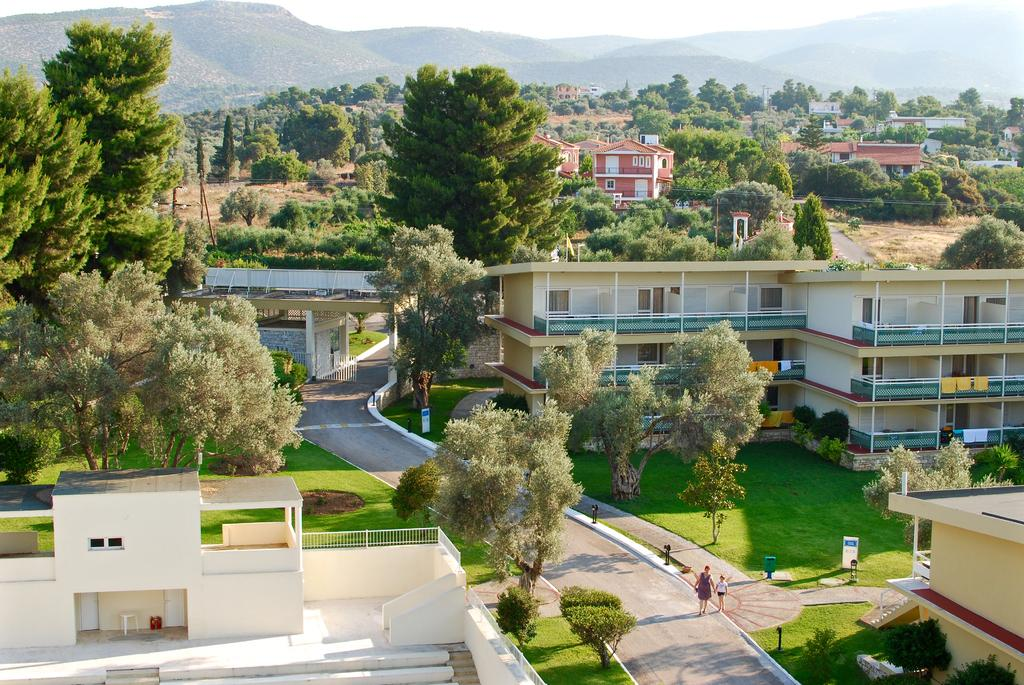What is the primary activity of the people in the image? The people in the image are on the ground, which suggests they might be walking, sitting, or engaging in some other activity. What can be used to identify individuals in the image? Name boards are visible in the image, which can be used to identify individuals. What type of natural environment is present in the image? Grass, trees, and mountains are visible in the image, indicating a natural environment. What type of structures are present in the image? Buildings are present in the image, suggesting an urban or developed area. What might people be wearing in the image? Clothes are visible in the image, which suggests that the people are dressed appropriately for the activity or setting. What other objects can be seen in the image? There are some objects in the image, but their specific nature is not mentioned in the facts. What type of drink is being served in the image? There is no mention of a drink in the image, so it cannot be determined from the facts provided. What type of brush is being used to create the artwork in the image? There is no artwork or brush present in the image, so it cannot be determined from the facts provided. 